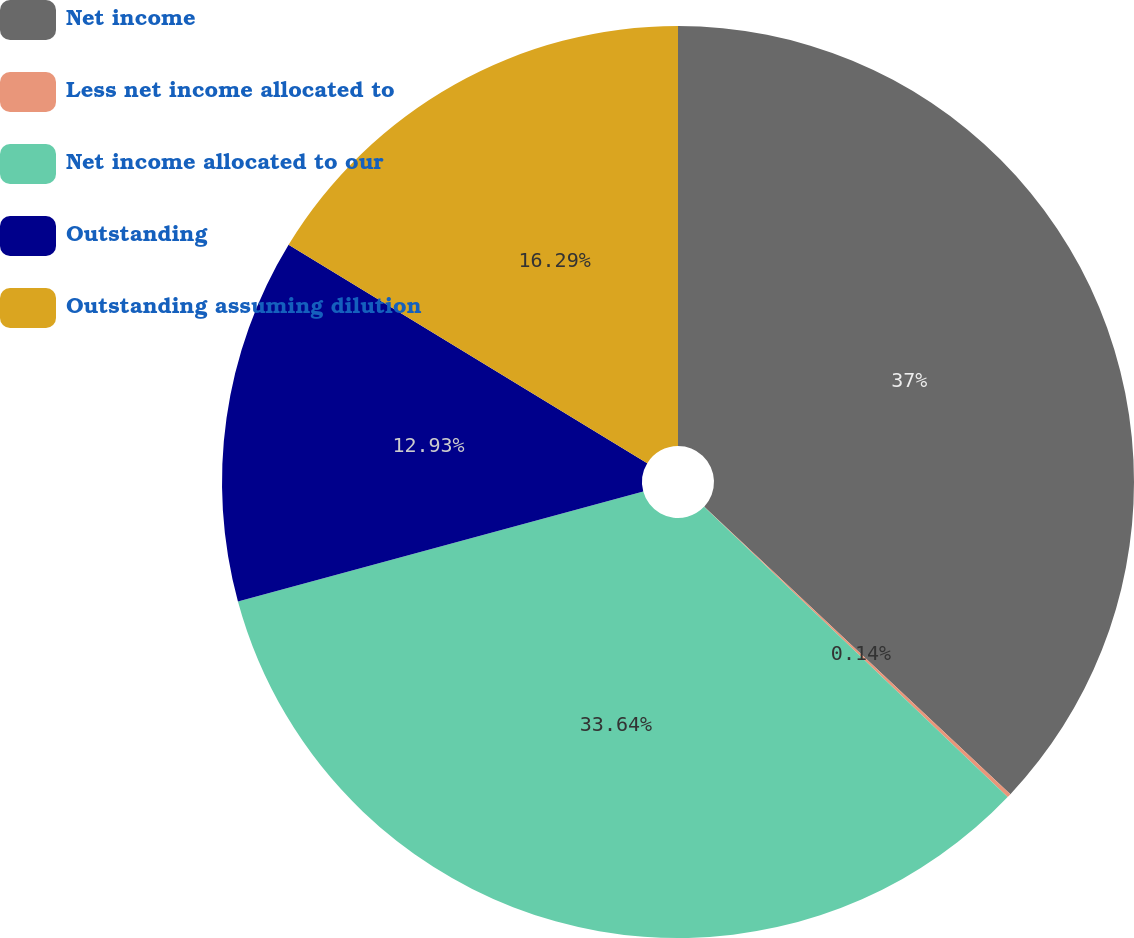Convert chart to OTSL. <chart><loc_0><loc_0><loc_500><loc_500><pie_chart><fcel>Net income<fcel>Less net income allocated to<fcel>Net income allocated to our<fcel>Outstanding<fcel>Outstanding assuming dilution<nl><fcel>37.0%<fcel>0.14%<fcel>33.64%<fcel>12.93%<fcel>16.29%<nl></chart> 